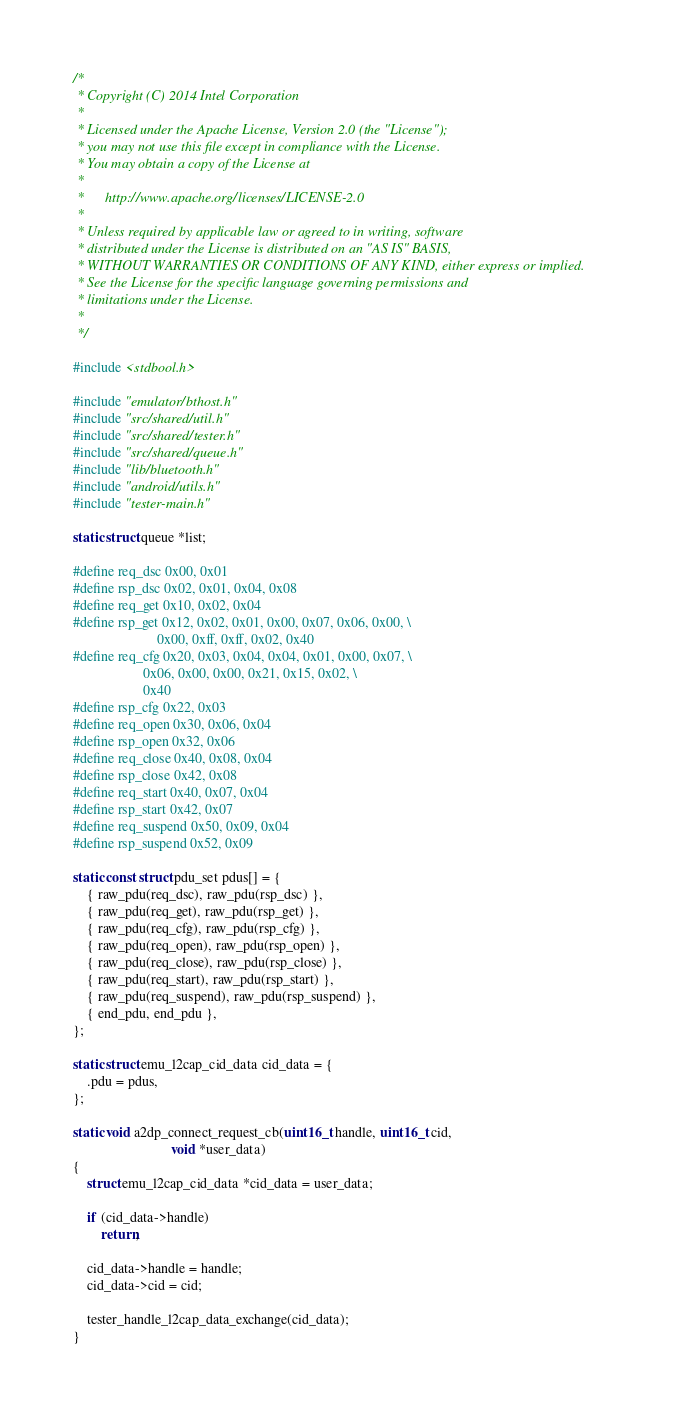Convert code to text. <code><loc_0><loc_0><loc_500><loc_500><_C_>/*
 * Copyright (C) 2014 Intel Corporation
 *
 * Licensed under the Apache License, Version 2.0 (the "License");
 * you may not use this file except in compliance with the License.
 * You may obtain a copy of the License at
 *
 *      http://www.apache.org/licenses/LICENSE-2.0
 *
 * Unless required by applicable law or agreed to in writing, software
 * distributed under the License is distributed on an "AS IS" BASIS,
 * WITHOUT WARRANTIES OR CONDITIONS OF ANY KIND, either express or implied.
 * See the License for the specific language governing permissions and
 * limitations under the License.
 *
 */

#include <stdbool.h>

#include "emulator/bthost.h"
#include "src/shared/util.h"
#include "src/shared/tester.h"
#include "src/shared/queue.h"
#include "lib/bluetooth.h"
#include "android/utils.h"
#include "tester-main.h"

static struct queue *list;

#define req_dsc 0x00, 0x01
#define rsp_dsc 0x02, 0x01, 0x04, 0x08
#define req_get 0x10, 0x02, 0x04
#define rsp_get 0x12, 0x02, 0x01, 0x00, 0x07, 0x06, 0x00, \
						0x00, 0xff, 0xff, 0x02, 0x40
#define req_cfg 0x20, 0x03, 0x04, 0x04, 0x01, 0x00, 0x07, \
					0x06, 0x00, 0x00, 0x21, 0x15, 0x02, \
					0x40
#define rsp_cfg 0x22, 0x03
#define req_open 0x30, 0x06, 0x04
#define rsp_open 0x32, 0x06
#define req_close 0x40, 0x08, 0x04
#define rsp_close 0x42, 0x08
#define req_start 0x40, 0x07, 0x04
#define rsp_start 0x42, 0x07
#define req_suspend 0x50, 0x09, 0x04
#define rsp_suspend 0x52, 0x09

static const struct pdu_set pdus[] = {
	{ raw_pdu(req_dsc), raw_pdu(rsp_dsc) },
	{ raw_pdu(req_get), raw_pdu(rsp_get) },
	{ raw_pdu(req_cfg), raw_pdu(rsp_cfg) },
	{ raw_pdu(req_open), raw_pdu(rsp_open) },
	{ raw_pdu(req_close), raw_pdu(rsp_close) },
	{ raw_pdu(req_start), raw_pdu(rsp_start) },
	{ raw_pdu(req_suspend), raw_pdu(rsp_suspend) },
	{ end_pdu, end_pdu },
};

static struct emu_l2cap_cid_data cid_data = {
	.pdu = pdus,
};

static void a2dp_connect_request_cb(uint16_t handle, uint16_t cid,
							void *user_data)
{
	struct emu_l2cap_cid_data *cid_data = user_data;

	if (cid_data->handle)
		return;

	cid_data->handle = handle;
	cid_data->cid = cid;

	tester_handle_l2cap_data_exchange(cid_data);
}
</code> 